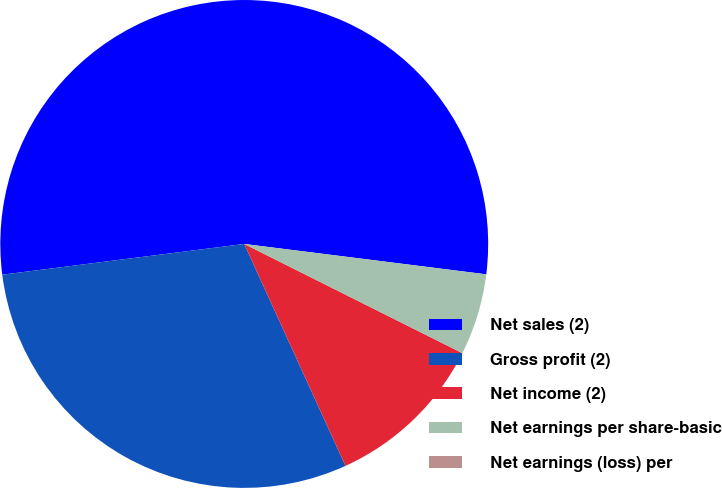<chart> <loc_0><loc_0><loc_500><loc_500><pie_chart><fcel>Net sales (2)<fcel>Gross profit (2)<fcel>Net income (2)<fcel>Net earnings per share-basic<fcel>Net earnings (loss) per<nl><fcel>54.0%<fcel>29.8%<fcel>10.8%<fcel>5.4%<fcel>0.0%<nl></chart> 